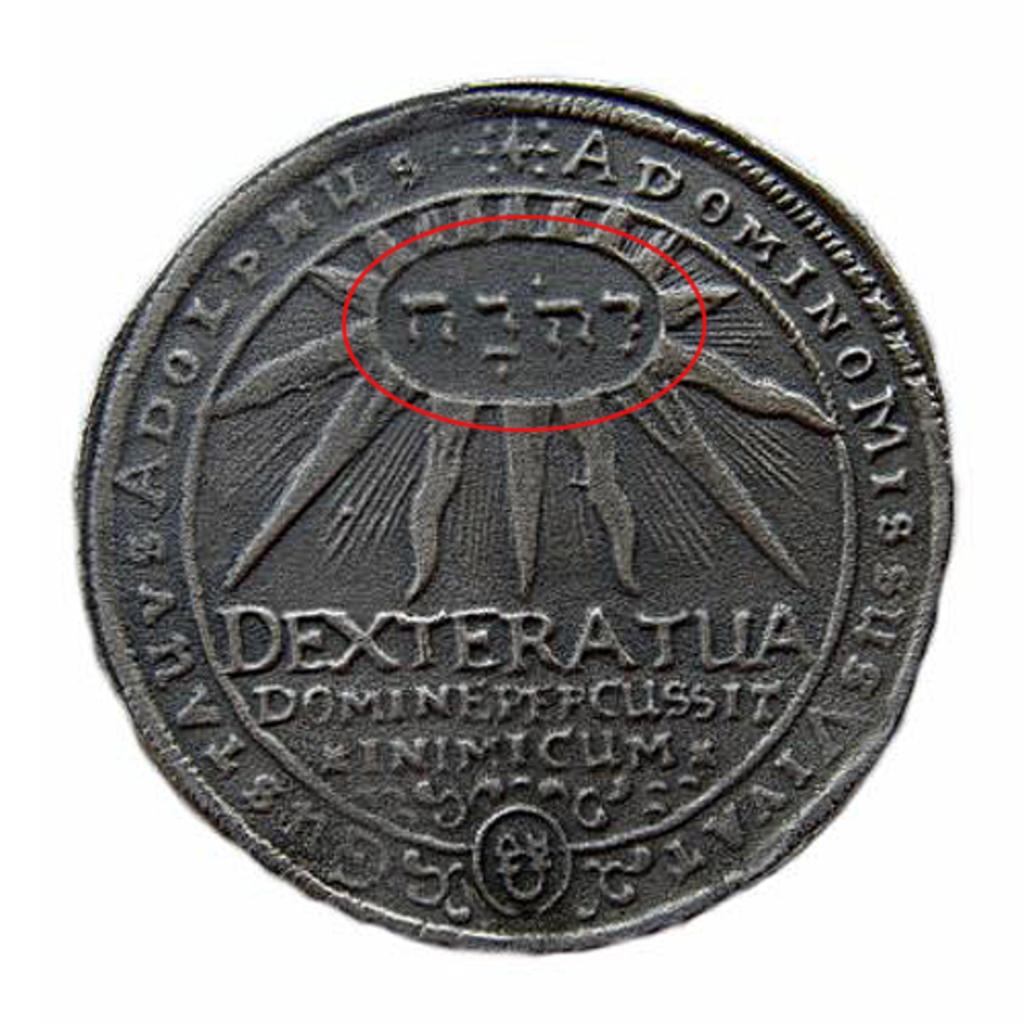What coin is this?
Give a very brief answer. Dexteratua. 